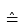Convert formula to latex. <formula><loc_0><loc_0><loc_500><loc_500>\hat { = }</formula> 